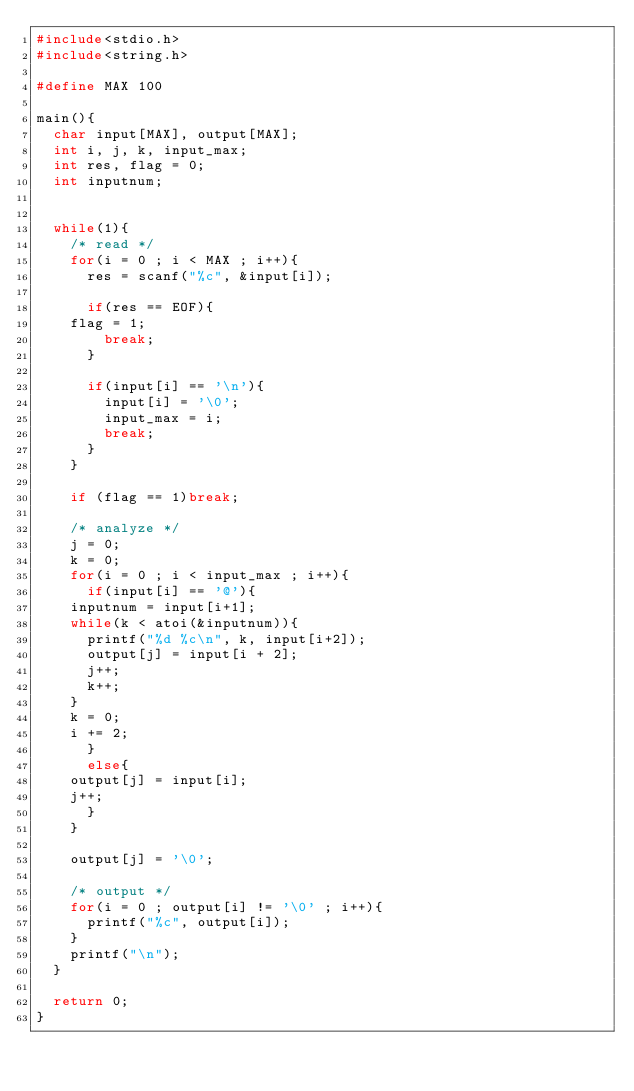Convert code to text. <code><loc_0><loc_0><loc_500><loc_500><_C_>#include<stdio.h>
#include<string.h>

#define MAX 100

main(){
  char input[MAX], output[MAX];
  int i, j, k, input_max;
  int res, flag = 0;
  int inputnum;


  while(1){
    /* read */
    for(i = 0 ; i < MAX ; i++){
      res = scanf("%c", &input[i]);

      if(res == EOF){
	flag = 1;
        break;
      }

      if(input[i] == '\n'){
        input[i] = '\0';
        input_max = i;
        break;
      }
    }

    if (flag == 1)break;

    /* analyze */
    j = 0;
    k = 0;
    for(i = 0 ; i < input_max ; i++){
      if(input[i] == '@'){
	inputnum = input[i+1];
	while(k < atoi(&inputnum)){
	  printf("%d %c\n", k, input[i+2]);
	  output[j] = input[i + 2];
	  j++;
	  k++;
	}
	k = 0;
	i += 2;
      }
      else{
	output[j] = input[i];
	j++;
      }
    }
    
    output[j] = '\0';
    
    /* output */
    for(i = 0 ; output[i] != '\0' ; i++){
      printf("%c", output[i]);
    }
    printf("\n");
  }

  return 0;
}</code> 